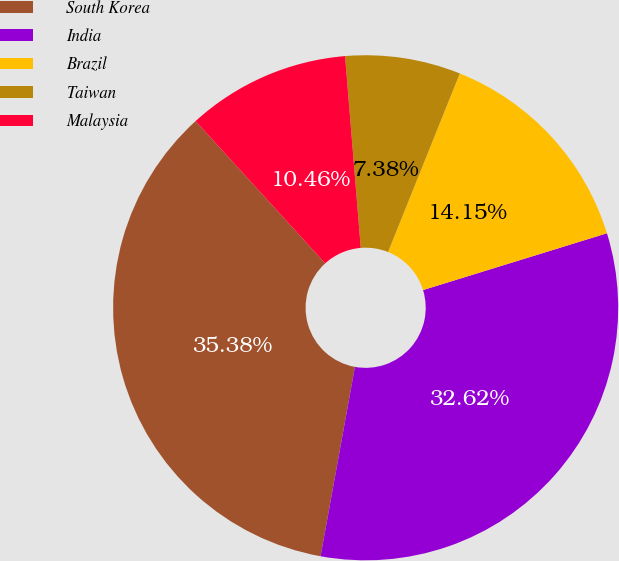<chart> <loc_0><loc_0><loc_500><loc_500><pie_chart><fcel>South Korea<fcel>India<fcel>Brazil<fcel>Taiwan<fcel>Malaysia<nl><fcel>35.38%<fcel>32.62%<fcel>14.15%<fcel>7.38%<fcel>10.46%<nl></chart> 